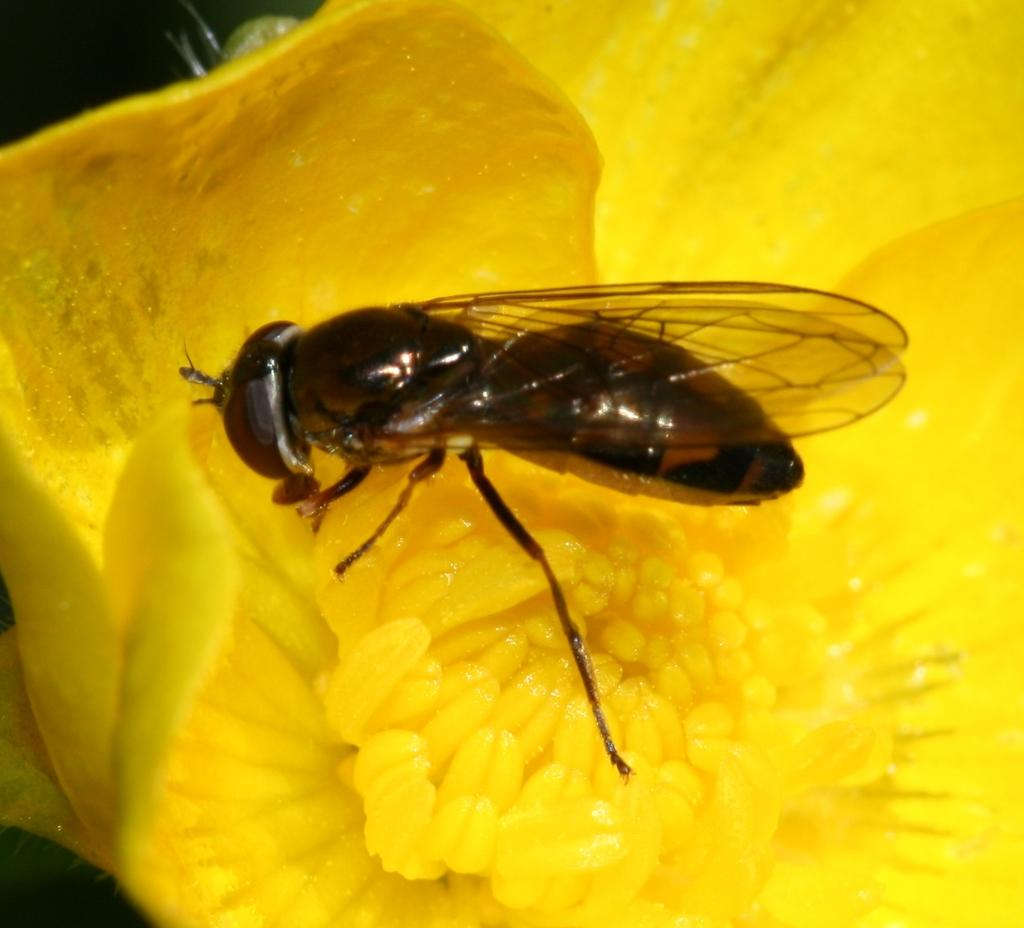What is present in the image that is not a part of the natural environment? There is a fly in the image. Where is the fly located in the image? The fly is on a flower. What type of match is the fly playing with in the image? There is no match present in the image, as it features a fly on a flower. How many beds are visible in the image? There are no beds visible in the image, as it features a fly on a flower. 